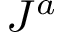Convert formula to latex. <formula><loc_0><loc_0><loc_500><loc_500>J ^ { a }</formula> 